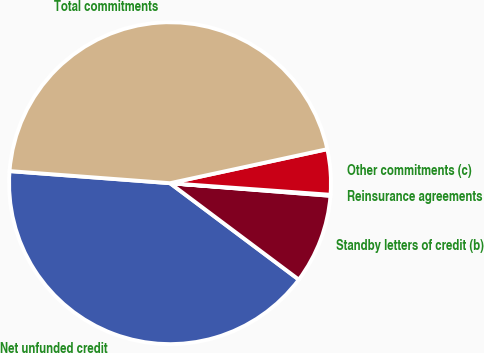Convert chart. <chart><loc_0><loc_0><loc_500><loc_500><pie_chart><fcel>Net unfunded credit<fcel>Standby letters of credit (b)<fcel>Reinsurance agreements<fcel>Other commitments (c)<fcel>Total commitments<nl><fcel>40.97%<fcel>8.98%<fcel>0.1%<fcel>4.54%<fcel>45.41%<nl></chart> 